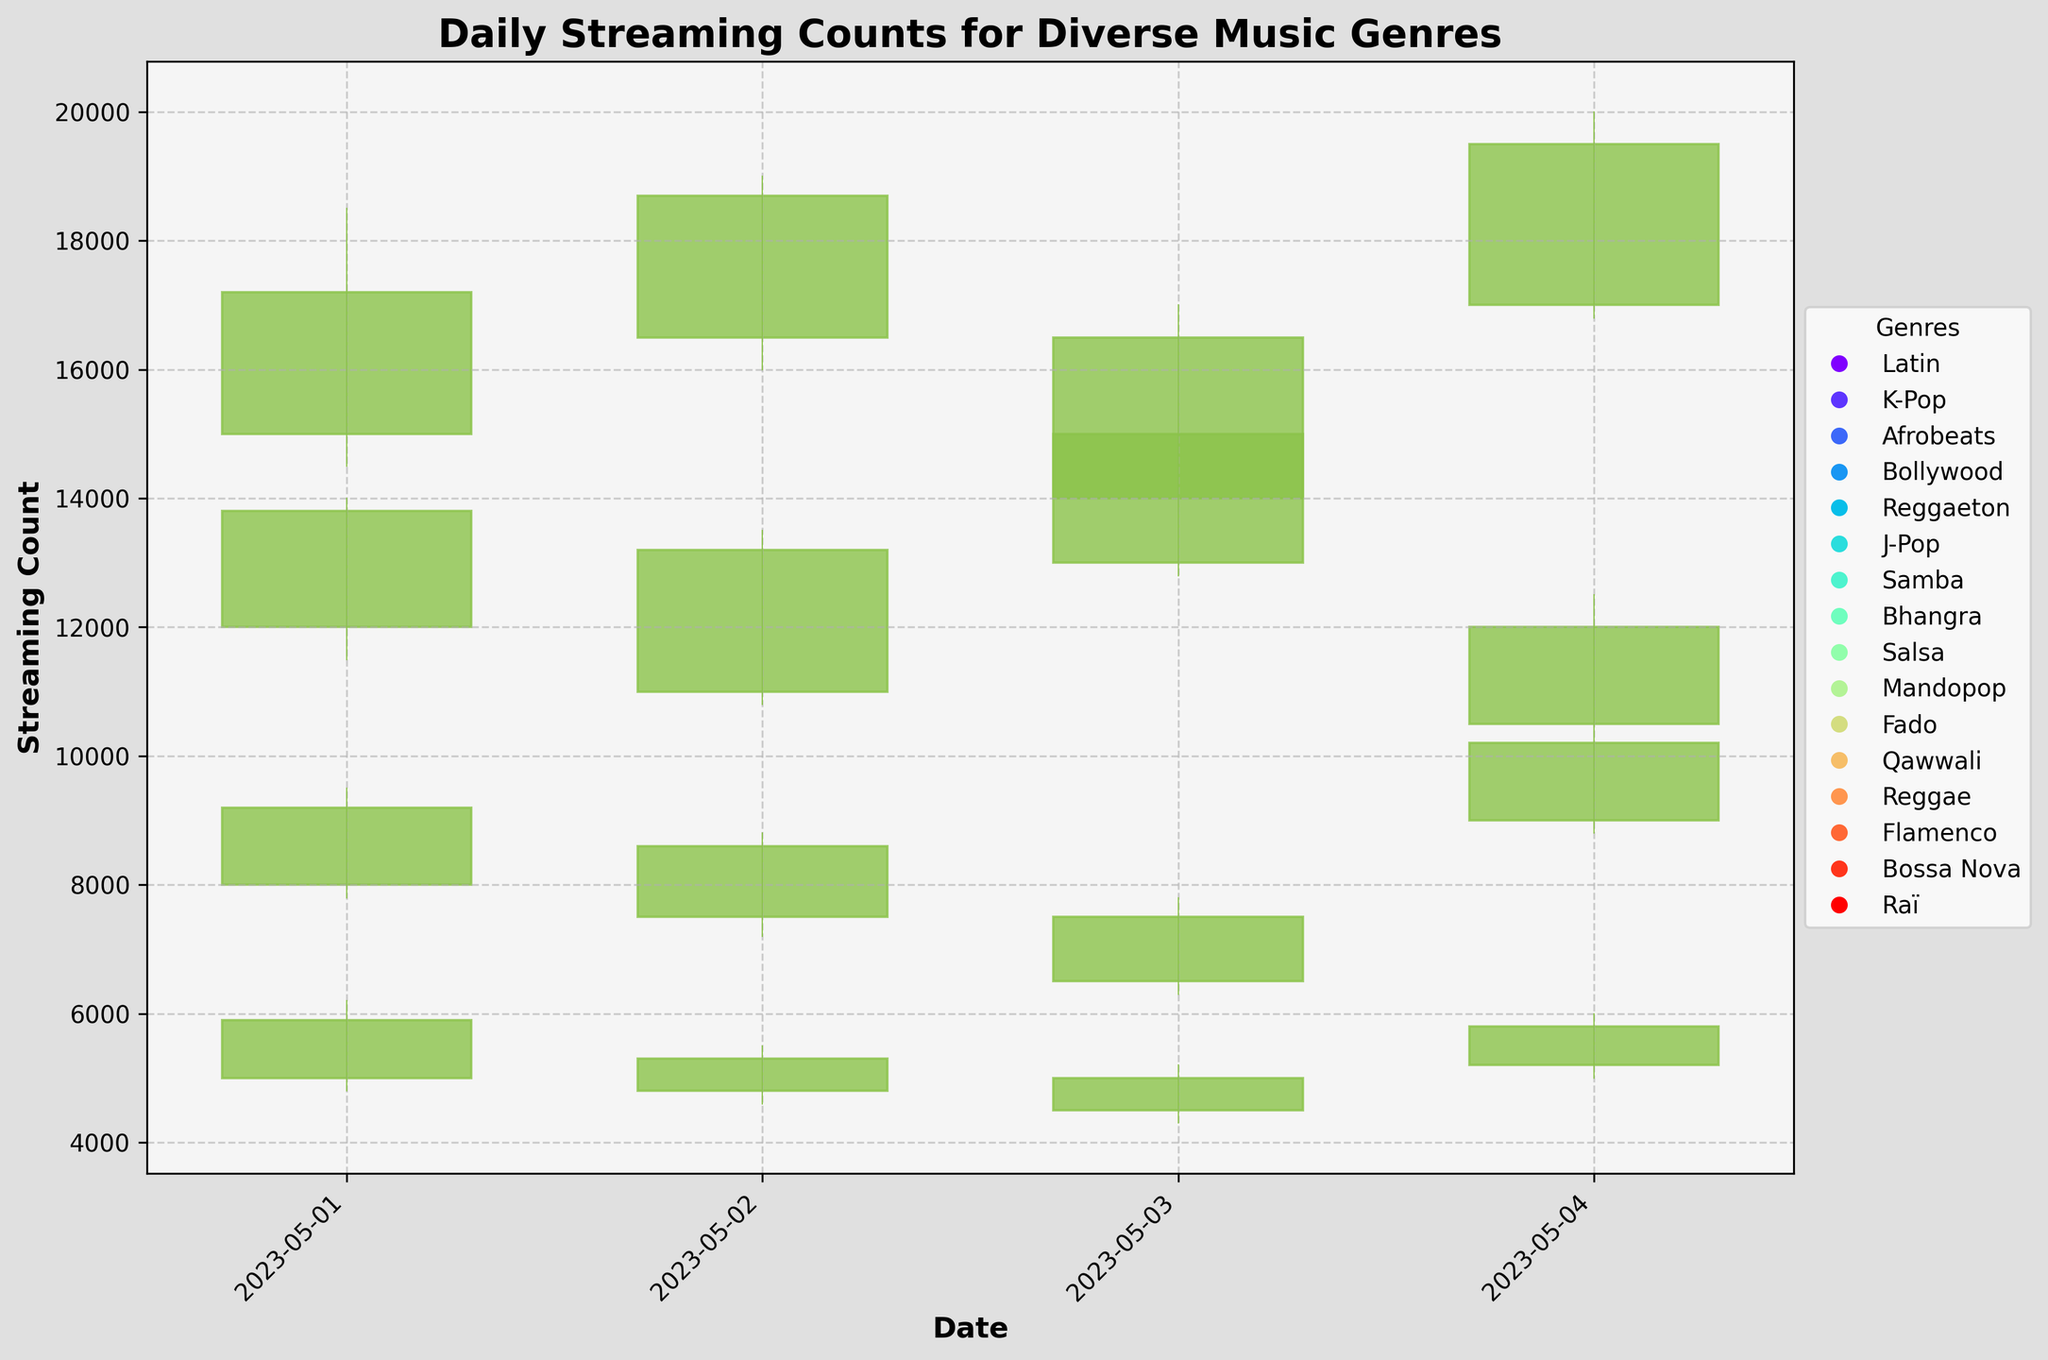What's the title of the chart? The title of the chart is displayed at the top of the figure. By looking directly at the top, the title can be easily identified.
Answer: Daily Streaming Counts for Diverse Music Genres Which genre has the highest high value on 2023-05-04? On the date 2023-05-04, the high values for each genre are plotted. By comparing these values, the genre with the highest value can be determined.
Answer: Reggae What is the low value of Bollywood on 2023-05-01? The low value for Bollywood on 2023-05-01 is plotted and can be found on the y-axis scale. By locating the specific bar for Bollywood on that date, the low value can be read.
Answer: 4800 On which date did the genre Salsa have a high value of 17000? The high value for Salsa is visually represented by the highest point of the OHLC bar on specific dates. By examining the high points for Salsa, the date where it reaches 17000 can be identified.
Answer: 2023-05-03 What's the average closing value of the genres on 2023-05-02? To find the average closing value, you sum the closing values of the genres on 2023-05-02 and then divide by the number of genres on that date. The genres on this date are Reggaeton, J-Pop, Samba, and Bhangra with closing values 18700, 13200, 8600, and 5300 respectively. Average = (18700 + 13200 + 8600 + 5300) / 4
Answer: 11400 Which age group has the widest range (difference between high and low) on 2023-05-01? For each age group on 2023-05-01, calculate the range as High - Low. Then compare these ranges to identify the widest one. The ranges are: [18500 - 14500 = 4000, 14000 - 11500 = 2500, 9500 - 7800 = 1700, 6200 - 4800 = 1400].
Answer: 18-24 Which genre has a downward trend on 2023-05-02 (Close is lower than Open)? A genre with a downward trend will have its close value lower than its open value. By examining the OHLC values for 2023-05-02, it can be identified.
Answer: J-Pop Compare the closing values of Bossa Nova and Reggae on 2023-05-04. Which one is higher? The closing values for Bossa Nova and Reggae on 2023-05-04 are shown in the chart. By comparing the closing value points, it can be seen which one is higher.
Answer: Reggae 